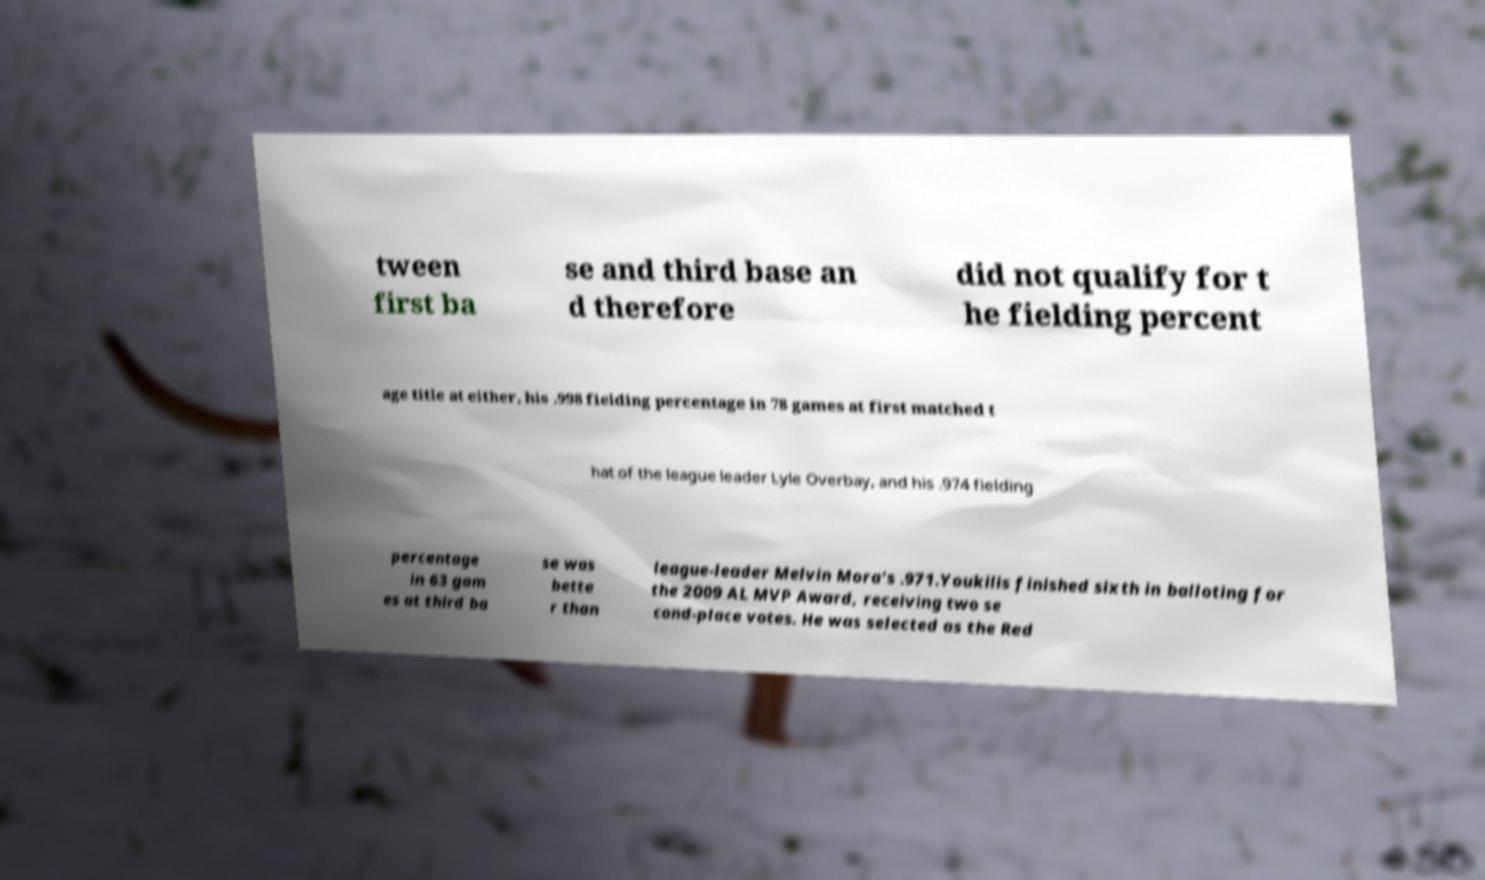For documentation purposes, I need the text within this image transcribed. Could you provide that? tween first ba se and third base an d therefore did not qualify for t he fielding percent age title at either, his .998 fielding percentage in 78 games at first matched t hat of the league leader Lyle Overbay, and his .974 fielding percentage in 63 gam es at third ba se was bette r than league-leader Melvin Mora's .971.Youkilis finished sixth in balloting for the 2009 AL MVP Award, receiving two se cond-place votes. He was selected as the Red 